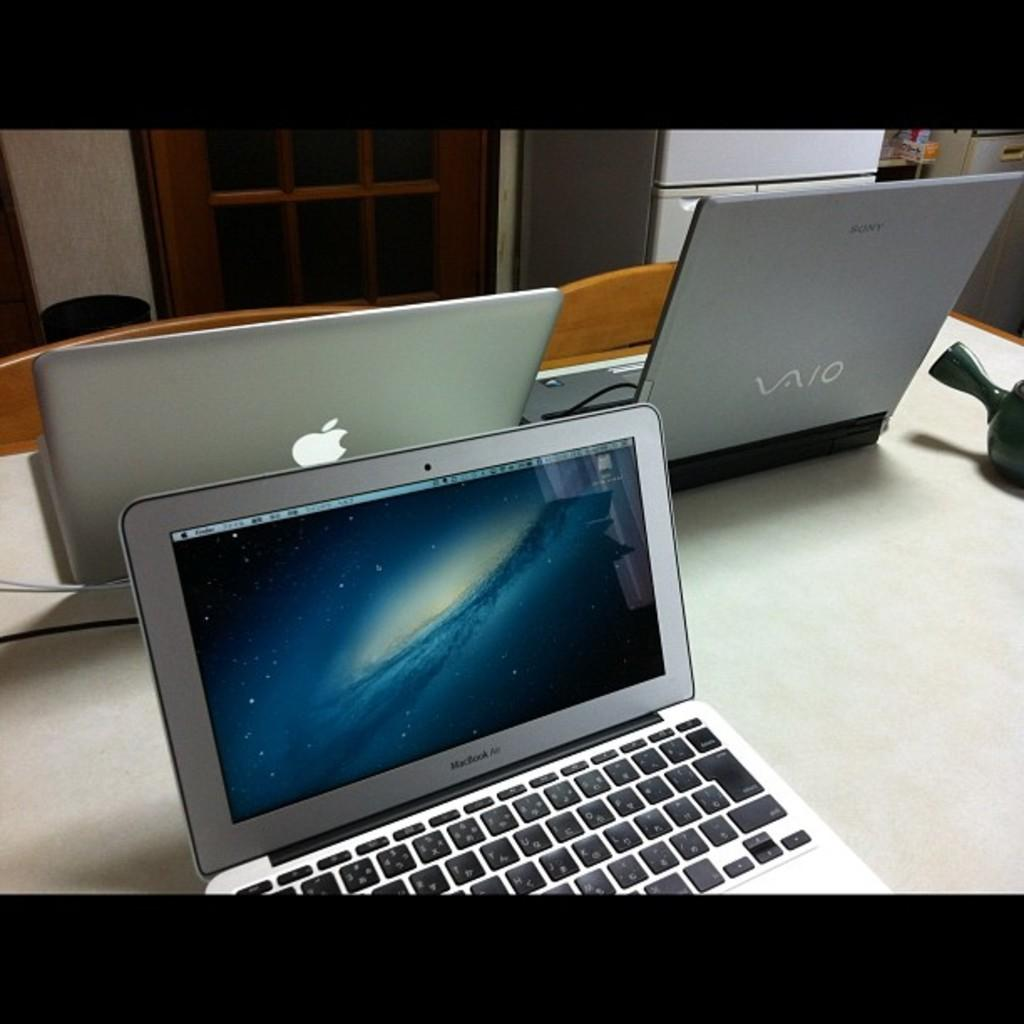Provide a one-sentence caption for the provided image. An apple laptop is sitting next to a vaio laptop. 